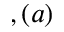<formula> <loc_0><loc_0><loc_500><loc_500>, ( a )</formula> 